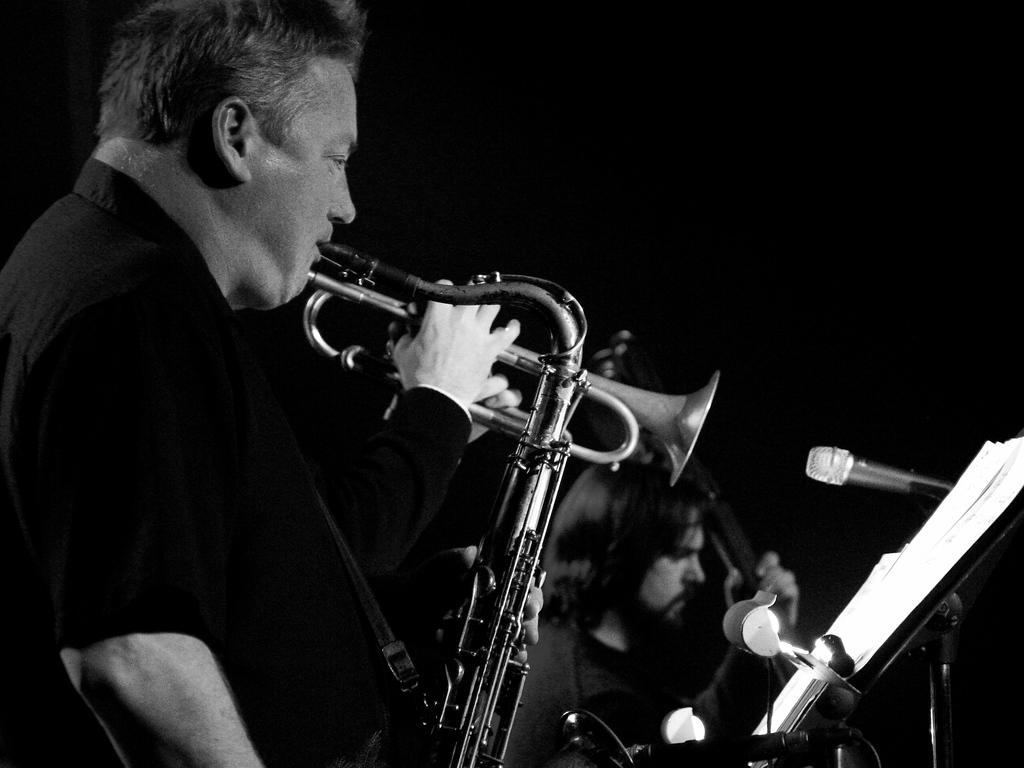Please provide a concise description of this image. In the image we can see black and white picture. We can see there are people wearing clothes. We can see there are even musical instruments, microphones and papers. 